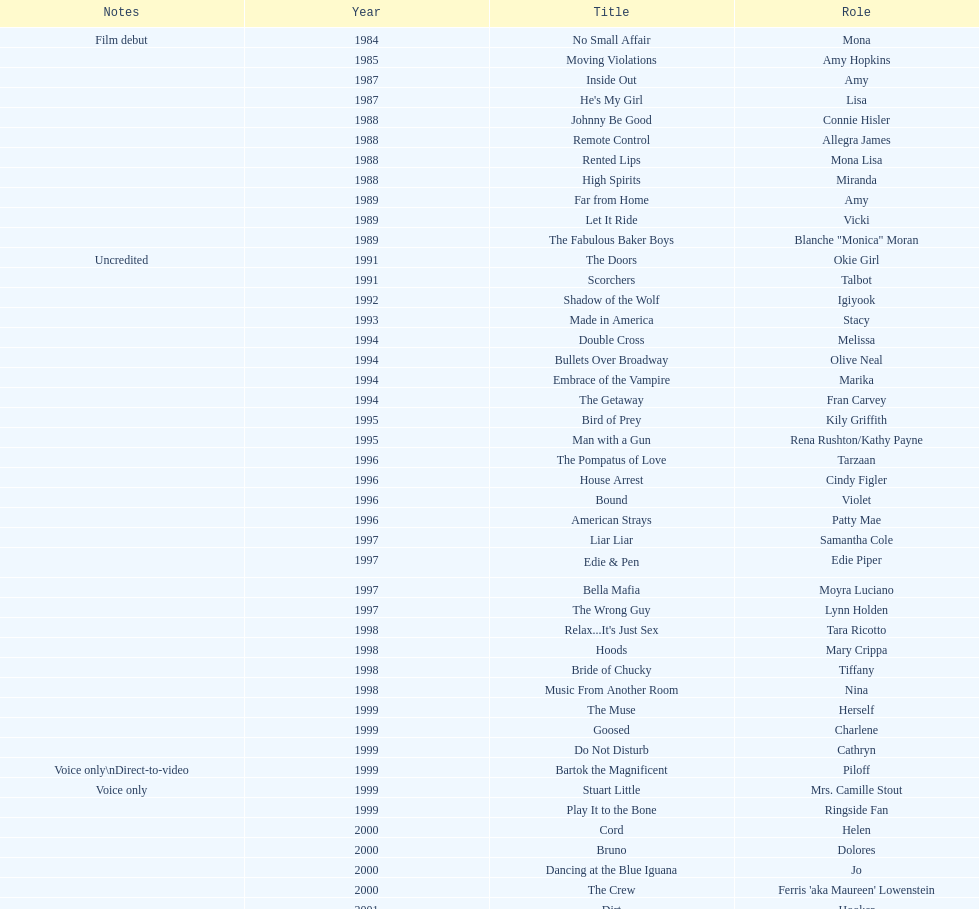How many movies does jennifer tilly play herself? 4. 